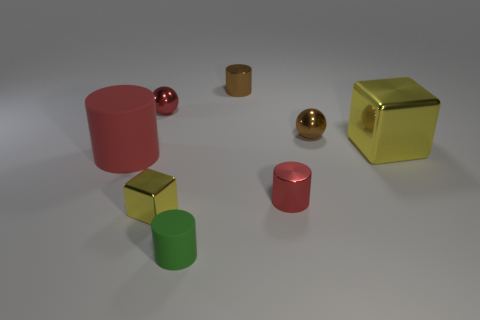What material is the small cylinder that is the same color as the large rubber cylinder?
Provide a short and direct response. Metal. There is a large block; is its color the same as the metal thing to the left of the small metal block?
Provide a short and direct response. No. What color is the large cube?
Give a very brief answer. Yellow. What number of things are small brown shiny spheres or matte cylinders?
Offer a very short reply. 3. There is a cube that is the same size as the green matte cylinder; what is it made of?
Provide a succinct answer. Metal. How big is the brown object in front of the brown shiny cylinder?
Offer a very short reply. Small. What is the material of the big yellow object?
Offer a very short reply. Metal. What number of things are yellow metallic cubes that are to the right of the small red metal cylinder or metallic objects left of the green thing?
Make the answer very short. 3. How many other objects are the same color as the big cylinder?
Ensure brevity in your answer.  2. There is a green matte object; is it the same shape as the red shiny thing that is on the right side of the green rubber object?
Provide a short and direct response. Yes. 